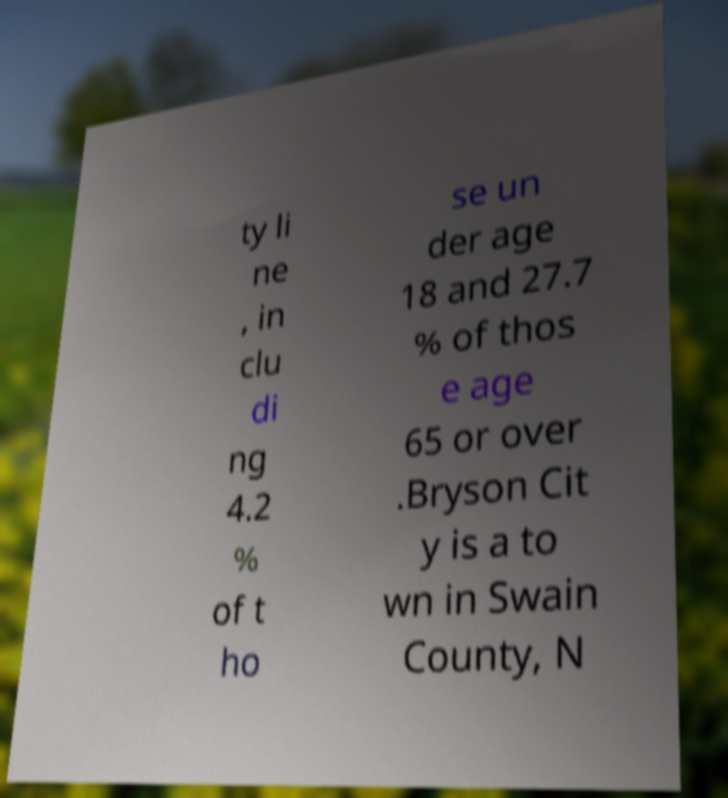Please read and relay the text visible in this image. What does it say? ty li ne , in clu di ng 4.2 % of t ho se un der age 18 and 27.7 % of thos e age 65 or over .Bryson Cit y is a to wn in Swain County, N 